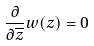Convert formula to latex. <formula><loc_0><loc_0><loc_500><loc_500>\frac { \partial } { \partial \overline { z } } w ( z ) = 0</formula> 